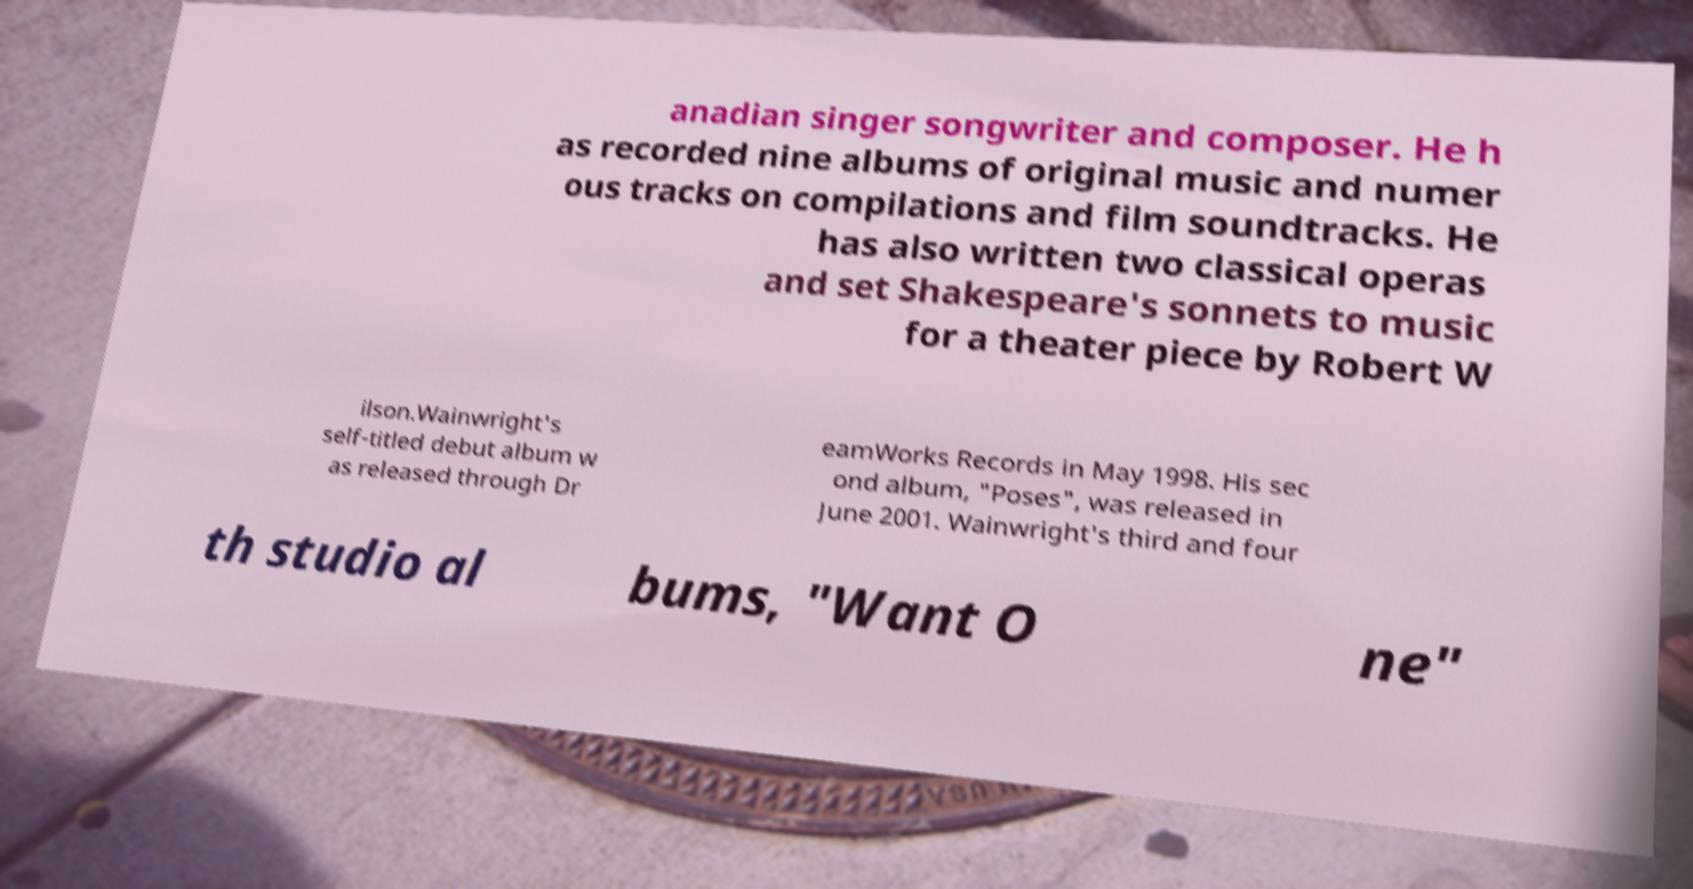Please identify and transcribe the text found in this image. anadian singer songwriter and composer. He h as recorded nine albums of original music and numer ous tracks on compilations and film soundtracks. He has also written two classical operas and set Shakespeare's sonnets to music for a theater piece by Robert W ilson.Wainwright's self-titled debut album w as released through Dr eamWorks Records in May 1998. His sec ond album, "Poses", was released in June 2001. Wainwright's third and four th studio al bums, "Want O ne" 